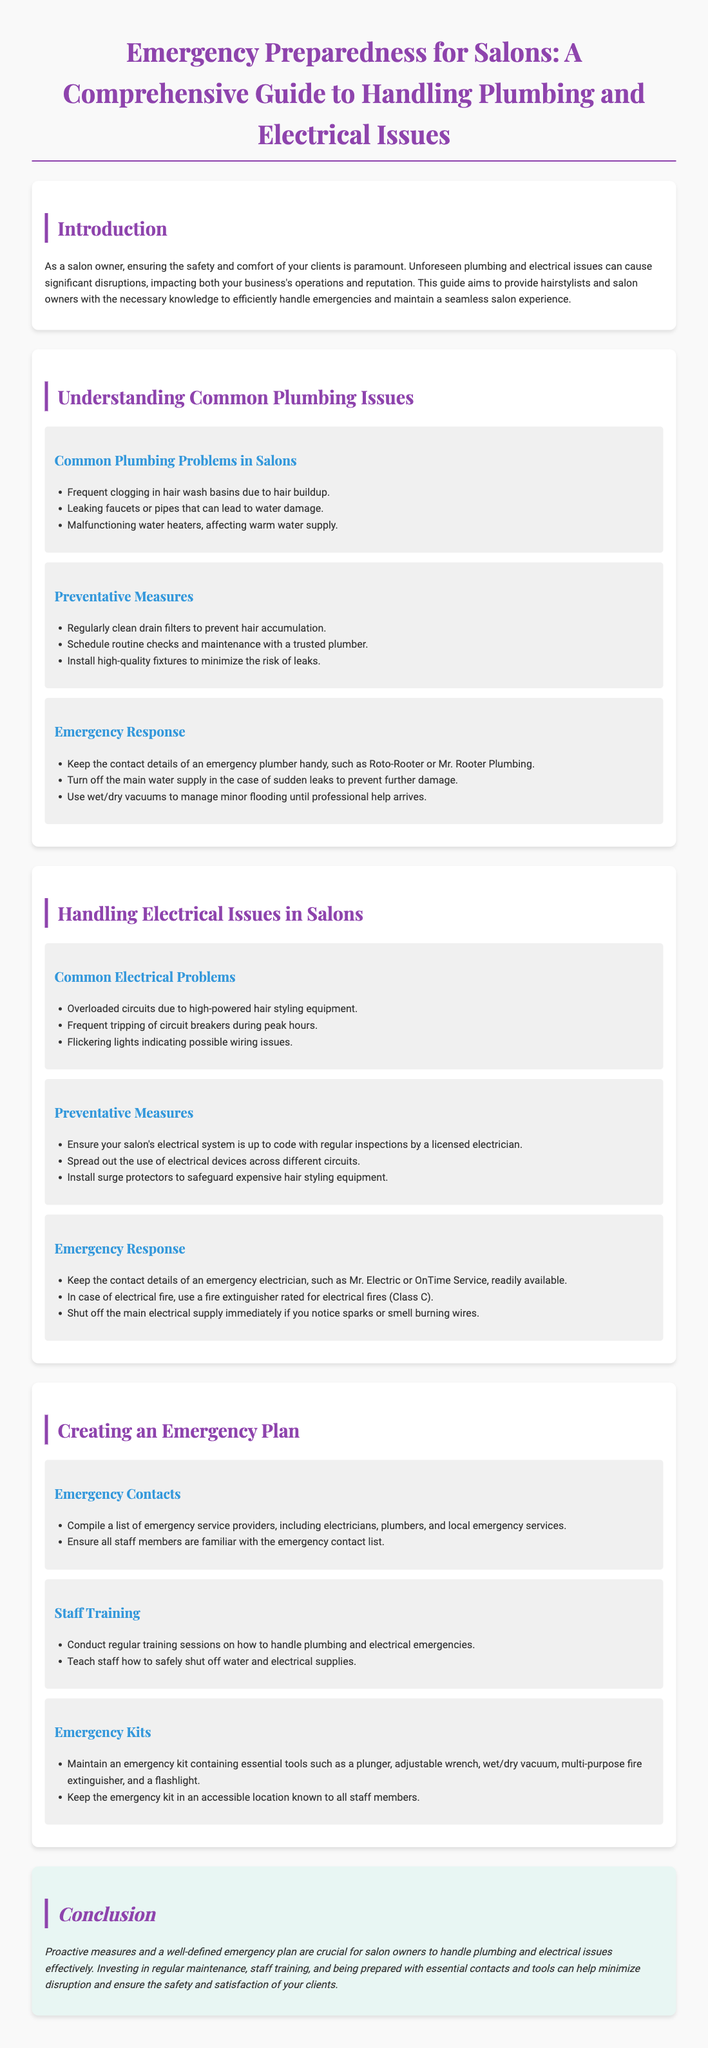What are common plumbing problems in salons? The document lists specific common plumbing problems that salons face, including frequent clogging in hair wash basins due to hair buildup.
Answer: Frequent clogging, leaking faucets, malfunctioning water heaters What is a preventative measure for plumbing issues? One of the preventative measures mentioned in the document is regular cleaning of drain filters to prevent hair accumulation.
Answer: Regularly clean drain filters What kind of fire extinguisher should be used for electrical fires? The document specifies that a fire extinguisher rated for electrical fires (Class C) should be used.
Answer: Class C Who should be contacted in case of electrical issues? Emergency electricians such as Mr. Electric or OnTime Service are mentioned as contacts for electrical problems.
Answer: Mr. Electric, OnTime Service What should you do in case of sudden leaks? According to the document, you should turn off the main water supply to prevent further damage.
Answer: Turn off the main water supply What is included in the emergency kit for salons? The document lists essential tools that should be included in an emergency kit, like a plunger and multi-purpose fire extinguisher.
Answer: Plunger, adjustable wrench, wet/dry vacuum, fire extinguisher, flashlight How can salon staff be prepared for emergencies? The document suggests that conducting regular training sessions on how to handle plumbing and electrical emergencies can prepare staff.
Answer: Conduct regular training sessions What should be familiar to all staff members in case of an emergency? The document emphasizes that all staff members should be familiar with the emergency contact list.
Answer: Emergency contact list 